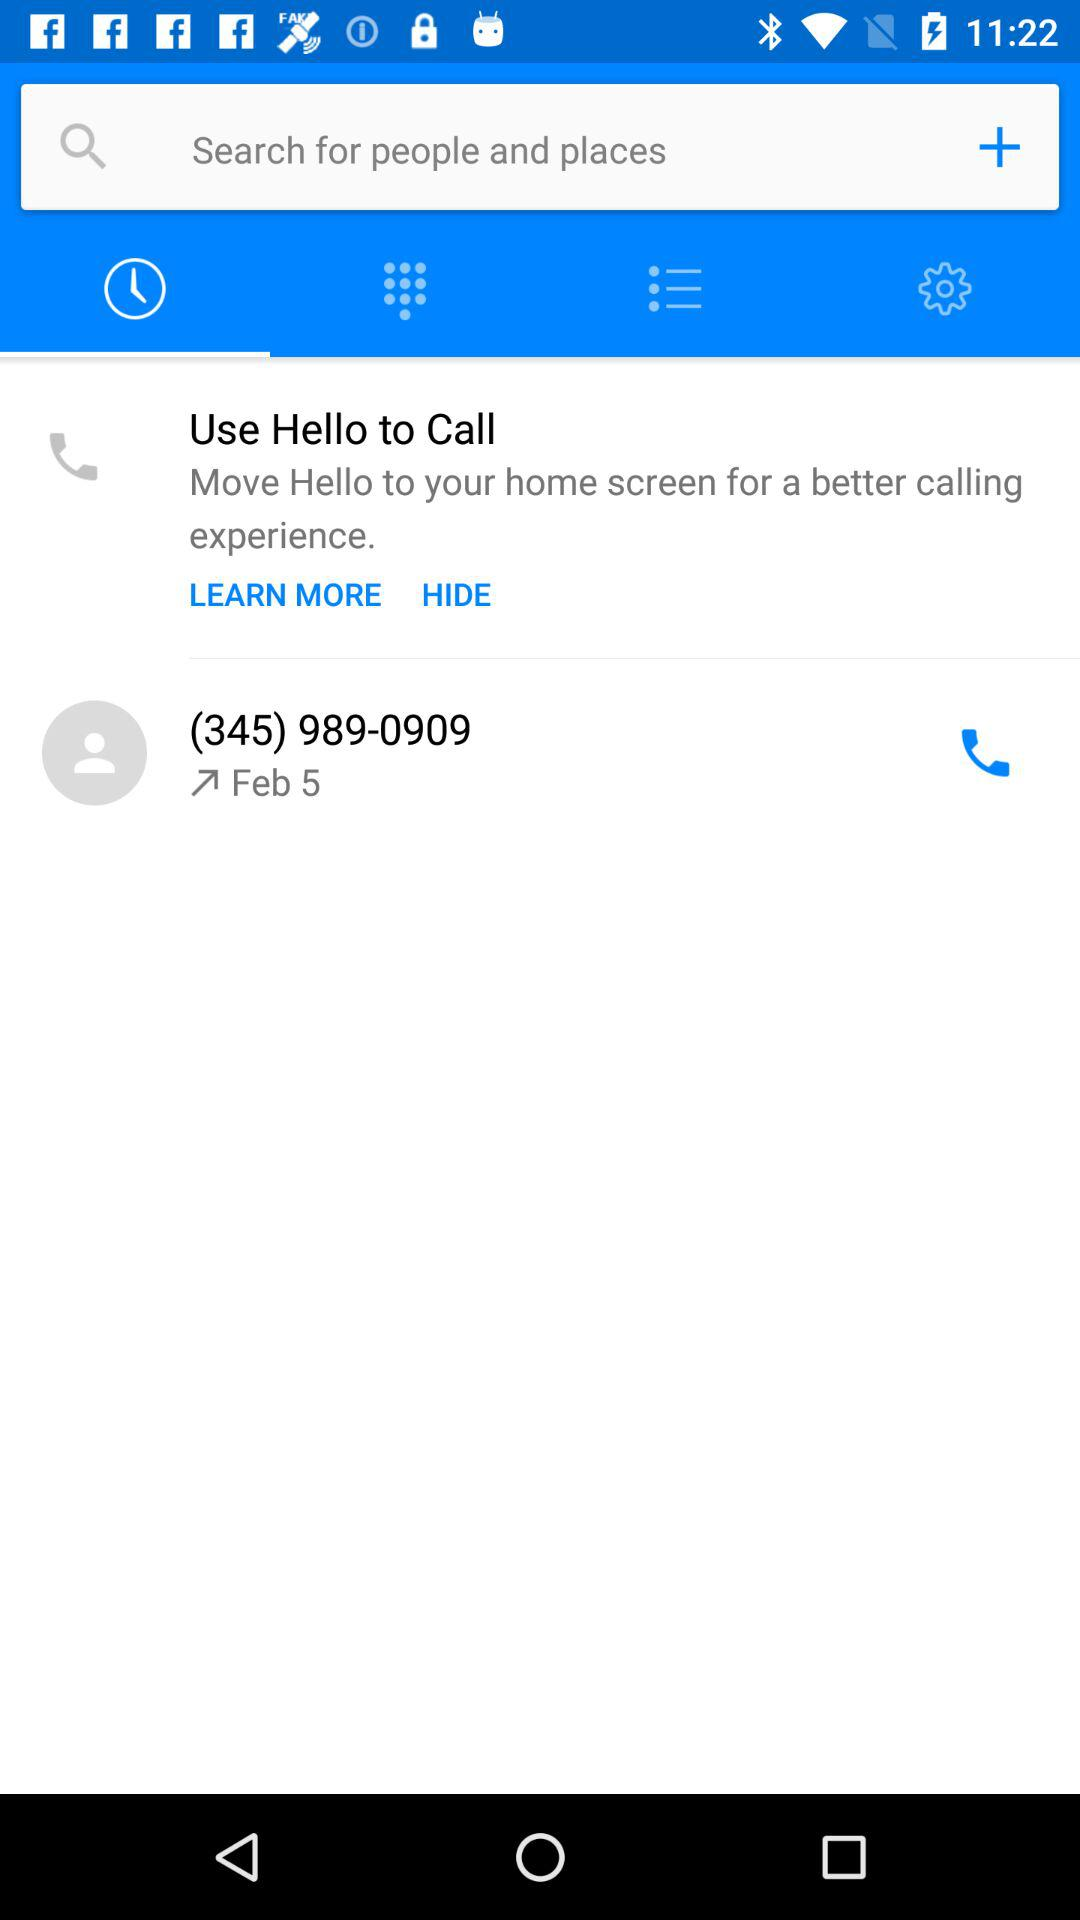Which version of the application is this?
When the provided information is insufficient, respond with <no answer>. <no answer> 